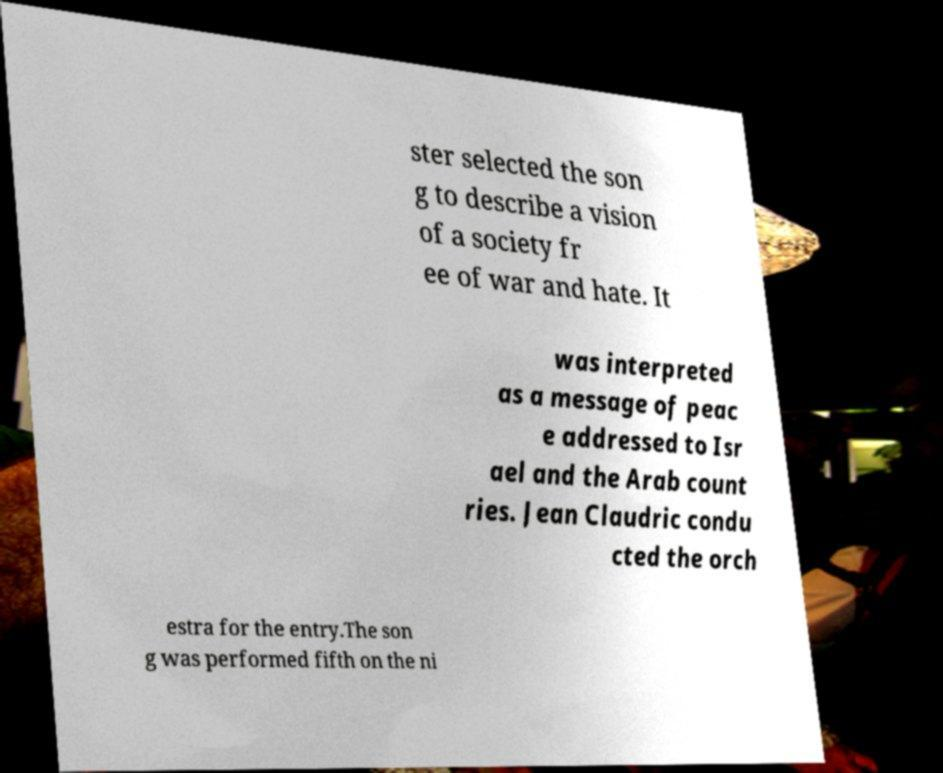Can you accurately transcribe the text from the provided image for me? ster selected the son g to describe a vision of a society fr ee of war and hate. It was interpreted as a message of peac e addressed to Isr ael and the Arab count ries. Jean Claudric condu cted the orch estra for the entry.The son g was performed fifth on the ni 